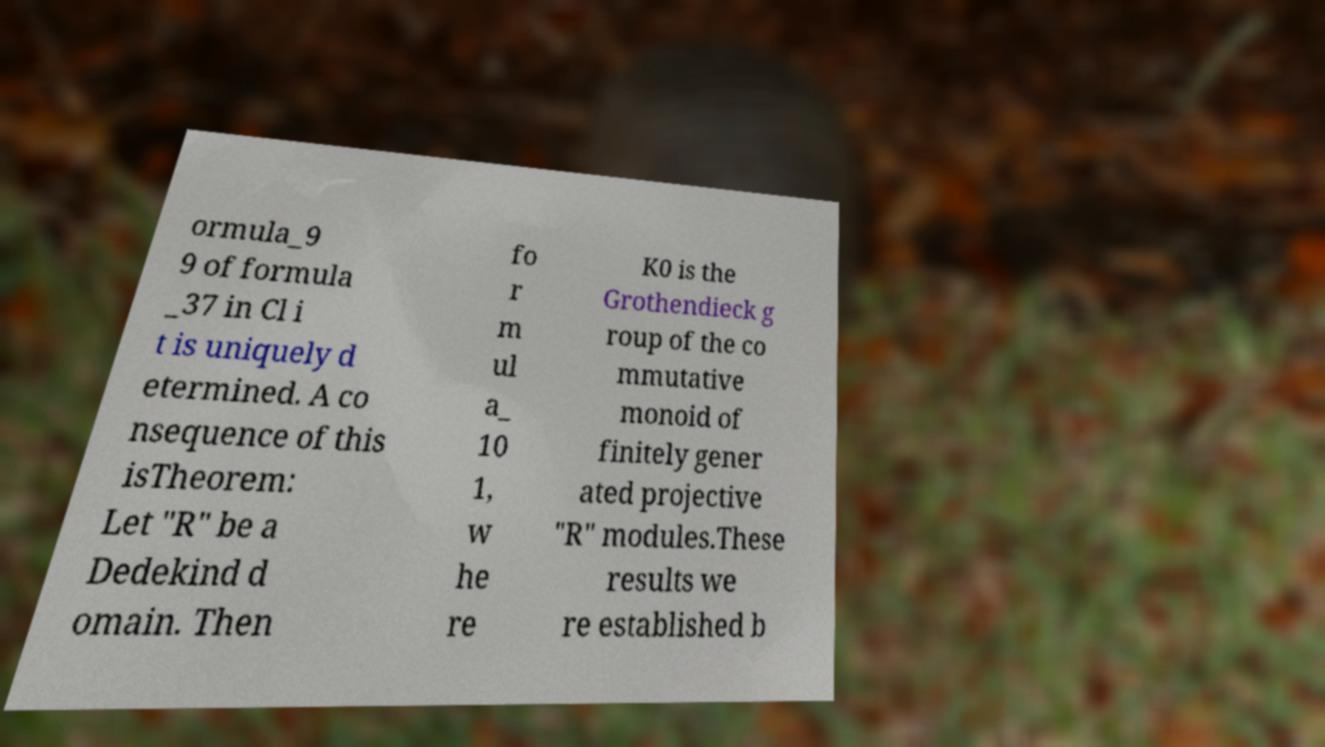Can you read and provide the text displayed in the image?This photo seems to have some interesting text. Can you extract and type it out for me? ormula_9 9 of formula _37 in Cl i t is uniquely d etermined. A co nsequence of this isTheorem: Let "R" be a Dedekind d omain. Then fo r m ul a_ 10 1, w he re K0 is the Grothendieck g roup of the co mmutative monoid of finitely gener ated projective "R" modules.These results we re established b 